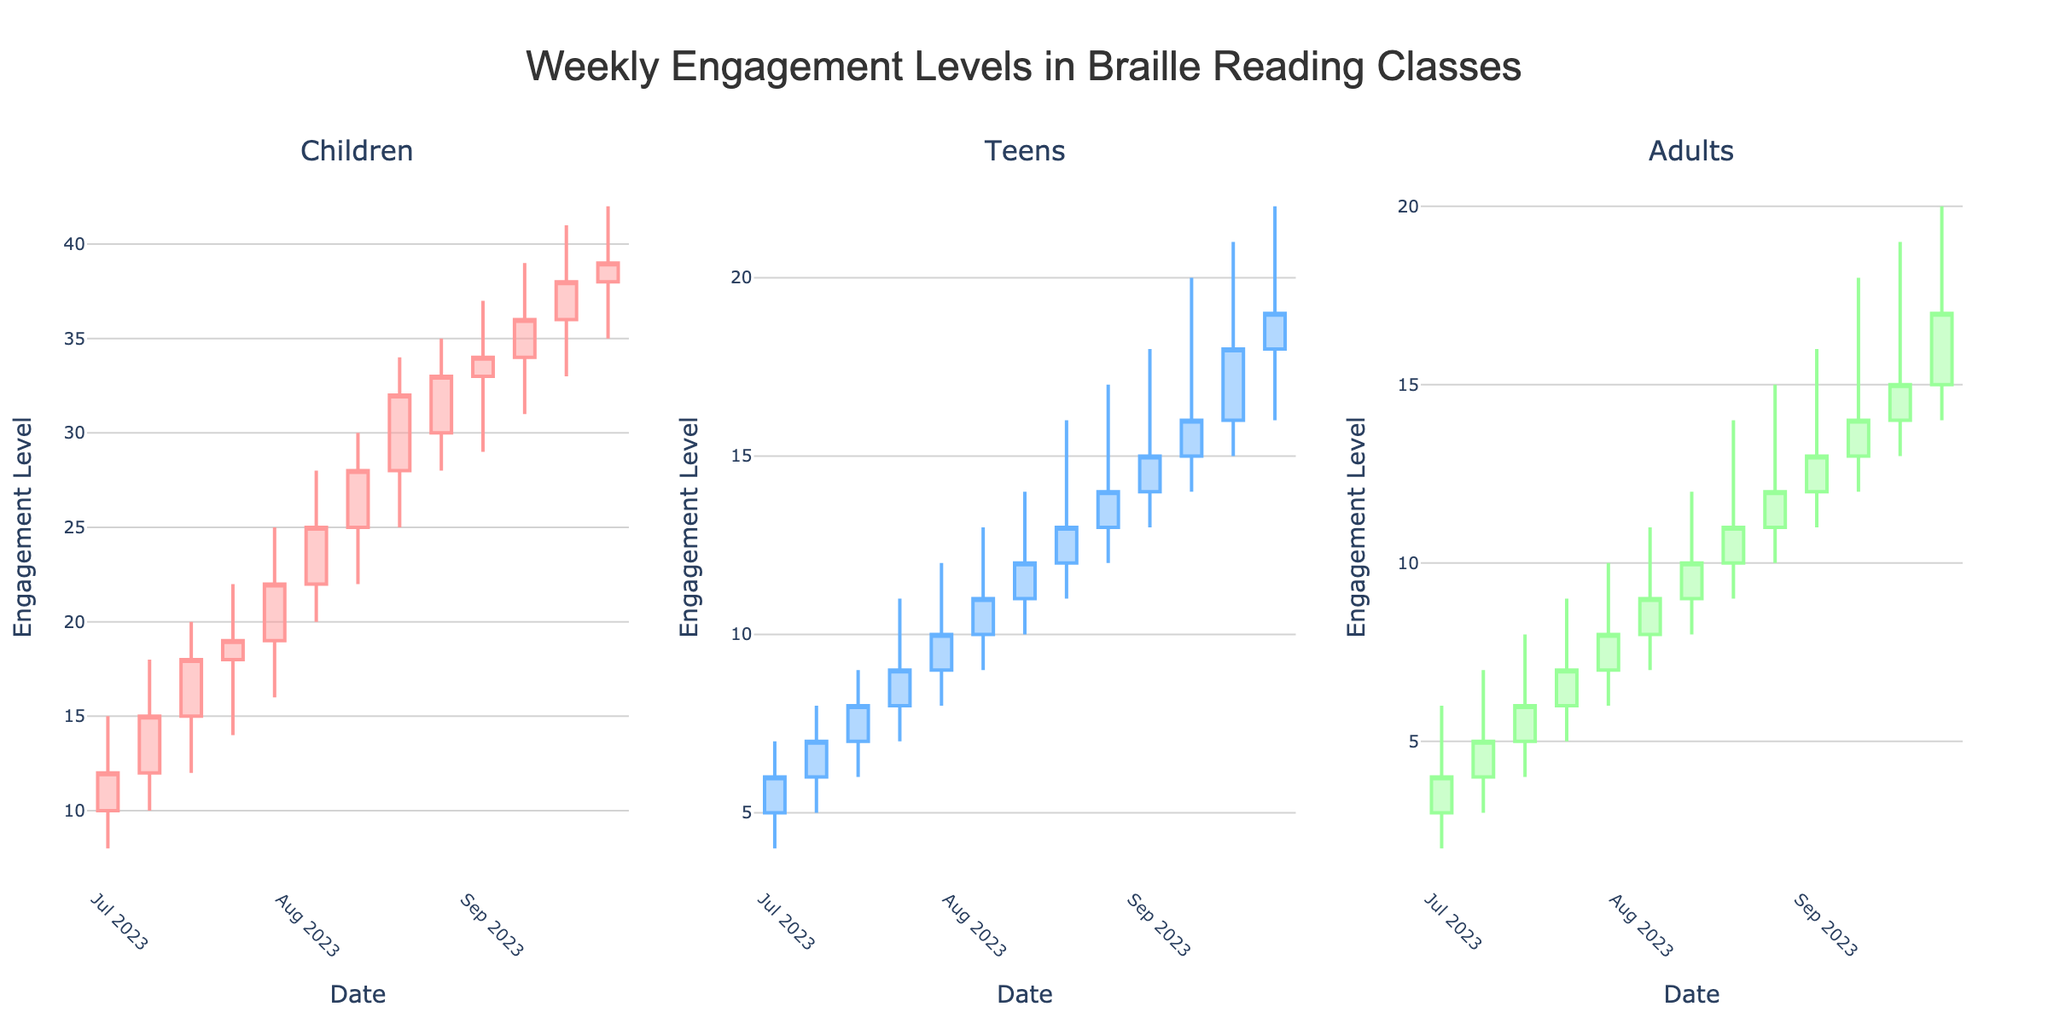How many subplots are there in the figure? The figure contains one subplot for each age group: Children, Teens, and Adults. This can be seen from the subplot titles for the three age groups.
Answer: 3 Which age group shows the highest engagement levels? By examining the highs of each candlestick subplot, it is evident that the Children group has the highest values, reaching up to 42.
Answer: Children What is the trend in engagement levels for the Children group over the quarter? By following the candlestick patterns from week to week, it is clear that the engagement levels for the Children group generally increase. The candlestick highs and closes progressively get higher.
Answer: Increasing Which week did the Teens group experience the highest engagement level? By looking at the candlestick high values, we see that the highest engagement for the Teens group was in the week of September 11, with a high value of 20.
Answer: September 11 How does the engagement level of Adults compare between the weeks of September 18 and September 25? Comparing the high values for these two weeks, Adults have a high of 19 on September 18 and 20 on September 25, indicating a slight increase.
Answer: Increase During which week did the Children group have the most significant drop in engagement levels? Drops or decreases in engagement can be seen by comparing the opening values of one week to the closing values of the previous week. Here, the most significant drop is from September 18 (close 38) to September 25 (open 38, which did not drop).
Answer: None What is the engagement level range for the Adults group in the week of August 28? For this week, the low value is 10 and the high value is 15, showing the range of engagement levels.
Answer: 5 How did the closing values for the Teens group change between August 7 and August 21? The closing values on August 7 and August 21 are 11 and 13, respectively. The closing value increased by 2 over these two weeks.
Answer: Increased by 2 What pattern is displayed in the closing values of the Children group from the beginning to the end of the quarter? The closing values start from 12 and steadily increase to 39 by the end of the quarter, showing a consistent upward trend.
Answer: Upward trend What is the average high value for the Adults group over the entire quarter? Adding all the high values for the Adults group (6, 7, 8, 9, 10, 11, 12, 14, 15, 16, 18, 19, 20) gives 155. Dividing by the number of data points (13) gives an average of approximately 11.92.
Answer: 11.92 